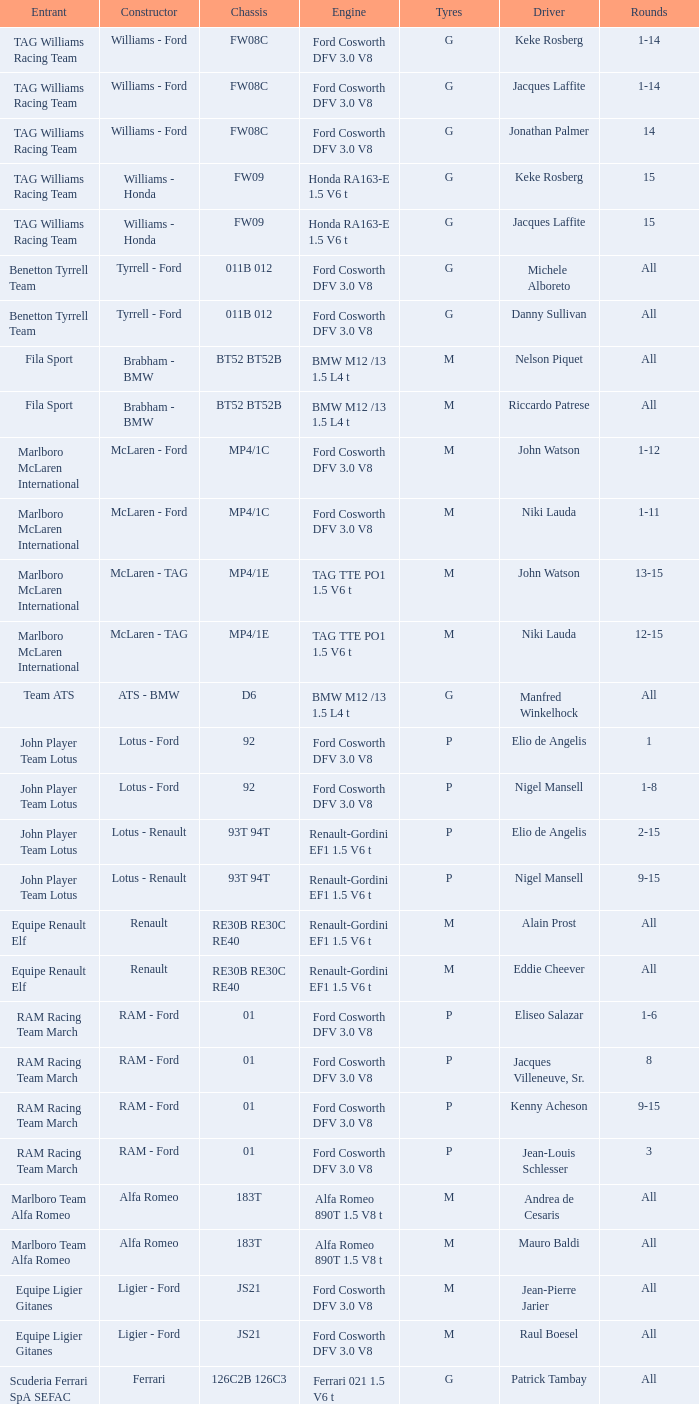Which constructor is responsible for piercarlo ghinzani's vehicle with a ford cosworth dfv 3.0 v8 engine? Osella - Ford. 